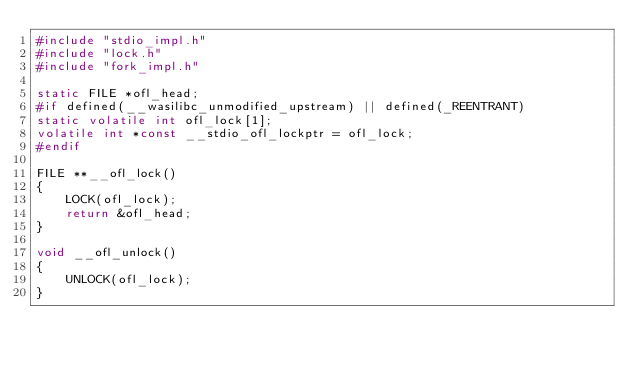Convert code to text. <code><loc_0><loc_0><loc_500><loc_500><_C_>#include "stdio_impl.h"
#include "lock.h"
#include "fork_impl.h"

static FILE *ofl_head;
#if defined(__wasilibc_unmodified_upstream) || defined(_REENTRANT)
static volatile int ofl_lock[1];
volatile int *const __stdio_ofl_lockptr = ofl_lock;
#endif

FILE **__ofl_lock()
{
	LOCK(ofl_lock);
	return &ofl_head;
}

void __ofl_unlock()
{
	UNLOCK(ofl_lock);
}
</code> 